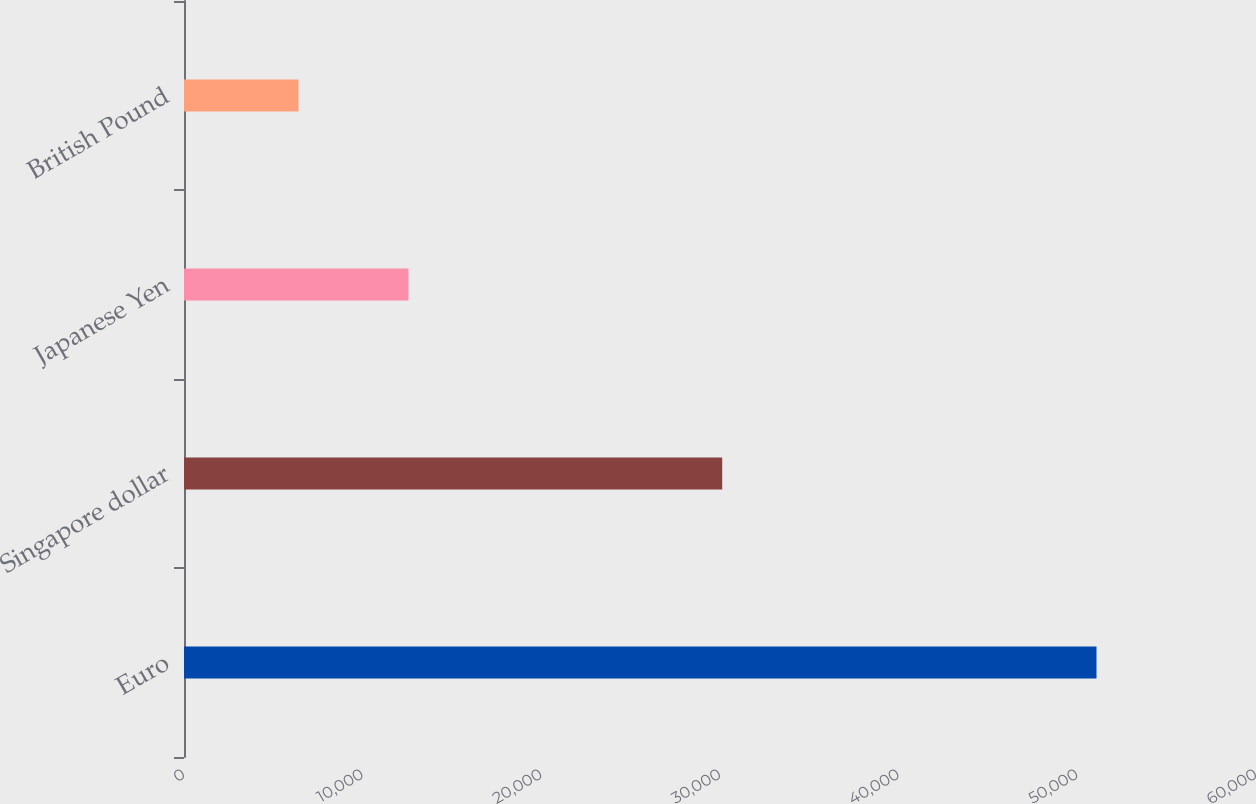<chart> <loc_0><loc_0><loc_500><loc_500><bar_chart><fcel>Euro<fcel>Singapore dollar<fcel>Japanese Yen<fcel>British Pound<nl><fcel>51072<fcel>30123<fcel>12563<fcel>6408<nl></chart> 